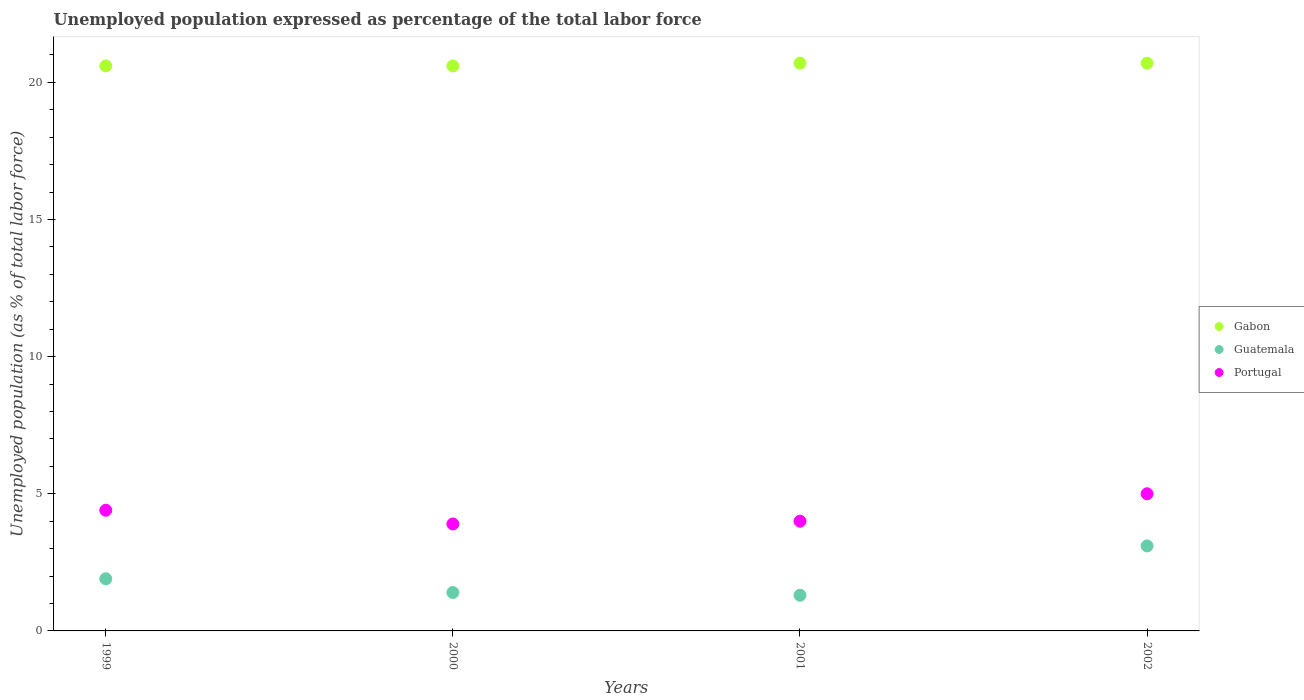Is the number of dotlines equal to the number of legend labels?
Your answer should be compact. Yes. Across all years, what is the maximum unemployment in in Gabon?
Provide a succinct answer. 20.7. Across all years, what is the minimum unemployment in in Portugal?
Provide a succinct answer. 3.9. What is the total unemployment in in Guatemala in the graph?
Give a very brief answer. 7.7. What is the difference between the unemployment in in Gabon in 1999 and the unemployment in in Guatemala in 2001?
Your answer should be very brief. 19.3. What is the average unemployment in in Guatemala per year?
Your answer should be very brief. 1.92. In the year 2002, what is the difference between the unemployment in in Portugal and unemployment in in Gabon?
Your answer should be compact. -15.7. Is the unemployment in in Portugal in 1999 less than that in 2001?
Your response must be concise. No. What is the difference between the highest and the second highest unemployment in in Guatemala?
Give a very brief answer. 1.2. What is the difference between the highest and the lowest unemployment in in Guatemala?
Make the answer very short. 1.8. Does the unemployment in in Portugal monotonically increase over the years?
Ensure brevity in your answer.  No. Is the unemployment in in Gabon strictly greater than the unemployment in in Portugal over the years?
Offer a very short reply. Yes. Is the unemployment in in Portugal strictly less than the unemployment in in Gabon over the years?
Keep it short and to the point. Yes. How many years are there in the graph?
Offer a very short reply. 4. What is the difference between two consecutive major ticks on the Y-axis?
Your answer should be very brief. 5. Does the graph contain any zero values?
Ensure brevity in your answer.  No. Where does the legend appear in the graph?
Provide a short and direct response. Center right. What is the title of the graph?
Give a very brief answer. Unemployed population expressed as percentage of the total labor force. Does "Uruguay" appear as one of the legend labels in the graph?
Your answer should be very brief. No. What is the label or title of the X-axis?
Your answer should be compact. Years. What is the label or title of the Y-axis?
Ensure brevity in your answer.  Unemployed population (as % of total labor force). What is the Unemployed population (as % of total labor force) of Gabon in 1999?
Provide a succinct answer. 20.6. What is the Unemployed population (as % of total labor force) of Guatemala in 1999?
Your answer should be compact. 1.9. What is the Unemployed population (as % of total labor force) in Portugal in 1999?
Provide a short and direct response. 4.4. What is the Unemployed population (as % of total labor force) in Gabon in 2000?
Keep it short and to the point. 20.6. What is the Unemployed population (as % of total labor force) in Guatemala in 2000?
Provide a succinct answer. 1.4. What is the Unemployed population (as % of total labor force) of Portugal in 2000?
Make the answer very short. 3.9. What is the Unemployed population (as % of total labor force) of Gabon in 2001?
Provide a short and direct response. 20.7. What is the Unemployed population (as % of total labor force) in Guatemala in 2001?
Your answer should be very brief. 1.3. What is the Unemployed population (as % of total labor force) of Gabon in 2002?
Offer a terse response. 20.7. What is the Unemployed population (as % of total labor force) in Guatemala in 2002?
Ensure brevity in your answer.  3.1. What is the Unemployed population (as % of total labor force) of Portugal in 2002?
Your response must be concise. 5. Across all years, what is the maximum Unemployed population (as % of total labor force) in Gabon?
Offer a very short reply. 20.7. Across all years, what is the maximum Unemployed population (as % of total labor force) of Guatemala?
Ensure brevity in your answer.  3.1. Across all years, what is the minimum Unemployed population (as % of total labor force) of Gabon?
Offer a very short reply. 20.6. Across all years, what is the minimum Unemployed population (as % of total labor force) in Guatemala?
Keep it short and to the point. 1.3. Across all years, what is the minimum Unemployed population (as % of total labor force) of Portugal?
Ensure brevity in your answer.  3.9. What is the total Unemployed population (as % of total labor force) in Gabon in the graph?
Provide a succinct answer. 82.6. What is the total Unemployed population (as % of total labor force) of Guatemala in the graph?
Provide a succinct answer. 7.7. What is the difference between the Unemployed population (as % of total labor force) in Portugal in 1999 and that in 2000?
Give a very brief answer. 0.5. What is the difference between the Unemployed population (as % of total labor force) of Portugal in 1999 and that in 2001?
Provide a succinct answer. 0.4. What is the difference between the Unemployed population (as % of total labor force) in Gabon in 1999 and that in 2002?
Keep it short and to the point. -0.1. What is the difference between the Unemployed population (as % of total labor force) of Guatemala in 1999 and that in 2002?
Your response must be concise. -1.2. What is the difference between the Unemployed population (as % of total labor force) of Portugal in 1999 and that in 2002?
Your answer should be compact. -0.6. What is the difference between the Unemployed population (as % of total labor force) in Guatemala in 2000 and that in 2001?
Your response must be concise. 0.1. What is the difference between the Unemployed population (as % of total labor force) in Portugal in 2000 and that in 2002?
Give a very brief answer. -1.1. What is the difference between the Unemployed population (as % of total labor force) of Guatemala in 2001 and that in 2002?
Your answer should be compact. -1.8. What is the difference between the Unemployed population (as % of total labor force) in Portugal in 2001 and that in 2002?
Offer a terse response. -1. What is the difference between the Unemployed population (as % of total labor force) in Gabon in 1999 and the Unemployed population (as % of total labor force) in Guatemala in 2000?
Provide a short and direct response. 19.2. What is the difference between the Unemployed population (as % of total labor force) of Gabon in 1999 and the Unemployed population (as % of total labor force) of Guatemala in 2001?
Your response must be concise. 19.3. What is the difference between the Unemployed population (as % of total labor force) in Guatemala in 1999 and the Unemployed population (as % of total labor force) in Portugal in 2001?
Offer a terse response. -2.1. What is the difference between the Unemployed population (as % of total labor force) in Gabon in 1999 and the Unemployed population (as % of total labor force) in Guatemala in 2002?
Offer a very short reply. 17.5. What is the difference between the Unemployed population (as % of total labor force) in Gabon in 1999 and the Unemployed population (as % of total labor force) in Portugal in 2002?
Your response must be concise. 15.6. What is the difference between the Unemployed population (as % of total labor force) in Gabon in 2000 and the Unemployed population (as % of total labor force) in Guatemala in 2001?
Your answer should be very brief. 19.3. What is the difference between the Unemployed population (as % of total labor force) of Guatemala in 2000 and the Unemployed population (as % of total labor force) of Portugal in 2001?
Your answer should be very brief. -2.6. What is the difference between the Unemployed population (as % of total labor force) in Gabon in 2000 and the Unemployed population (as % of total labor force) in Guatemala in 2002?
Provide a short and direct response. 17.5. What is the difference between the Unemployed population (as % of total labor force) in Gabon in 2001 and the Unemployed population (as % of total labor force) in Portugal in 2002?
Offer a terse response. 15.7. What is the difference between the Unemployed population (as % of total labor force) of Guatemala in 2001 and the Unemployed population (as % of total labor force) of Portugal in 2002?
Make the answer very short. -3.7. What is the average Unemployed population (as % of total labor force) of Gabon per year?
Give a very brief answer. 20.65. What is the average Unemployed population (as % of total labor force) of Guatemala per year?
Your answer should be compact. 1.93. What is the average Unemployed population (as % of total labor force) in Portugal per year?
Offer a very short reply. 4.33. In the year 1999, what is the difference between the Unemployed population (as % of total labor force) of Gabon and Unemployed population (as % of total labor force) of Guatemala?
Your response must be concise. 18.7. In the year 2000, what is the difference between the Unemployed population (as % of total labor force) in Gabon and Unemployed population (as % of total labor force) in Guatemala?
Ensure brevity in your answer.  19.2. In the year 2000, what is the difference between the Unemployed population (as % of total labor force) of Gabon and Unemployed population (as % of total labor force) of Portugal?
Your answer should be very brief. 16.7. In the year 2001, what is the difference between the Unemployed population (as % of total labor force) of Gabon and Unemployed population (as % of total labor force) of Portugal?
Offer a terse response. 16.7. In the year 2002, what is the difference between the Unemployed population (as % of total labor force) in Gabon and Unemployed population (as % of total labor force) in Guatemala?
Your response must be concise. 17.6. What is the ratio of the Unemployed population (as % of total labor force) of Guatemala in 1999 to that in 2000?
Keep it short and to the point. 1.36. What is the ratio of the Unemployed population (as % of total labor force) in Portugal in 1999 to that in 2000?
Ensure brevity in your answer.  1.13. What is the ratio of the Unemployed population (as % of total labor force) in Gabon in 1999 to that in 2001?
Make the answer very short. 1. What is the ratio of the Unemployed population (as % of total labor force) of Guatemala in 1999 to that in 2001?
Keep it short and to the point. 1.46. What is the ratio of the Unemployed population (as % of total labor force) of Portugal in 1999 to that in 2001?
Keep it short and to the point. 1.1. What is the ratio of the Unemployed population (as % of total labor force) in Guatemala in 1999 to that in 2002?
Your answer should be very brief. 0.61. What is the ratio of the Unemployed population (as % of total labor force) in Gabon in 2000 to that in 2001?
Provide a short and direct response. 1. What is the ratio of the Unemployed population (as % of total labor force) of Guatemala in 2000 to that in 2001?
Give a very brief answer. 1.08. What is the ratio of the Unemployed population (as % of total labor force) in Gabon in 2000 to that in 2002?
Offer a very short reply. 1. What is the ratio of the Unemployed population (as % of total labor force) in Guatemala in 2000 to that in 2002?
Provide a succinct answer. 0.45. What is the ratio of the Unemployed population (as % of total labor force) in Portugal in 2000 to that in 2002?
Your answer should be compact. 0.78. What is the ratio of the Unemployed population (as % of total labor force) in Gabon in 2001 to that in 2002?
Offer a terse response. 1. What is the ratio of the Unemployed population (as % of total labor force) in Guatemala in 2001 to that in 2002?
Provide a short and direct response. 0.42. What is the ratio of the Unemployed population (as % of total labor force) of Portugal in 2001 to that in 2002?
Make the answer very short. 0.8. What is the difference between the highest and the second highest Unemployed population (as % of total labor force) in Guatemala?
Provide a succinct answer. 1.2. What is the difference between the highest and the lowest Unemployed population (as % of total labor force) of Gabon?
Your response must be concise. 0.1. What is the difference between the highest and the lowest Unemployed population (as % of total labor force) in Guatemala?
Offer a terse response. 1.8. 